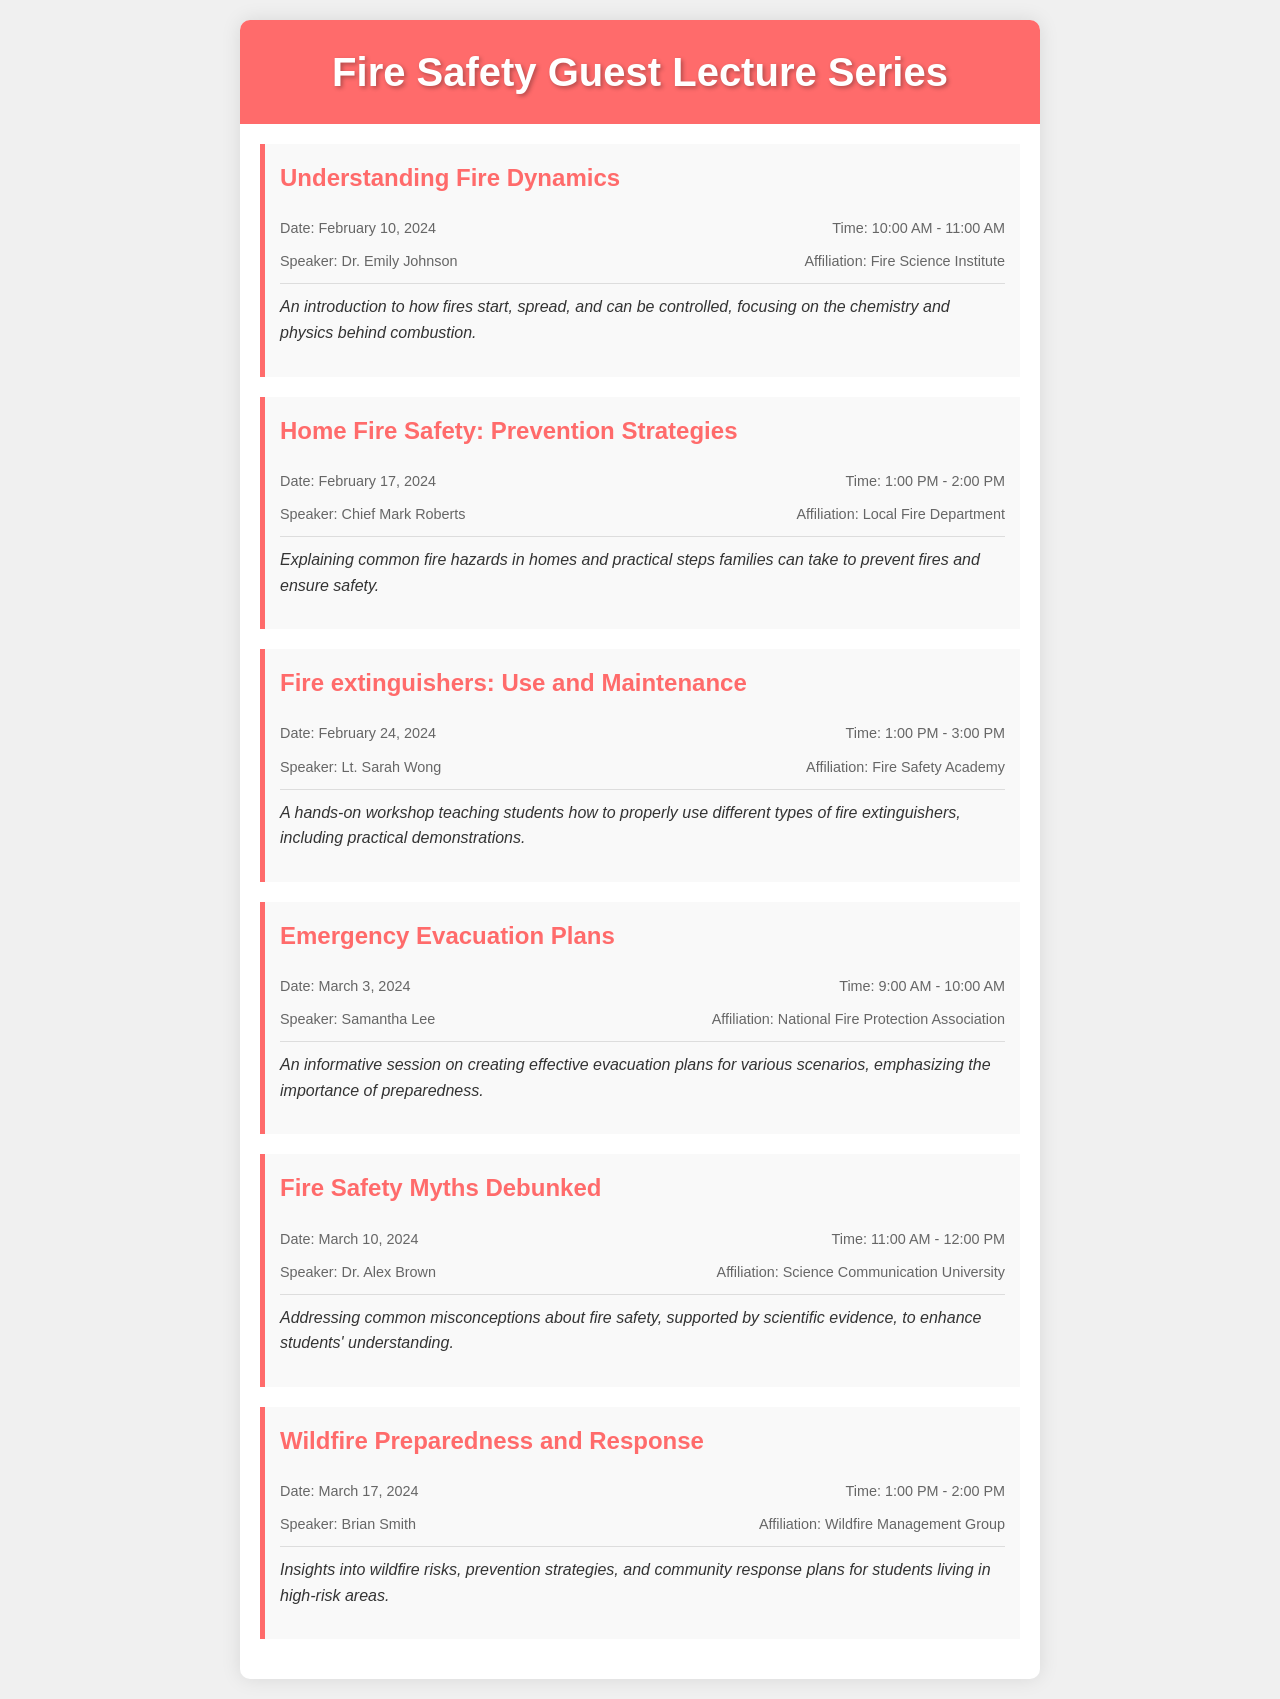What is the title of the first lecture? The title of the first lecture is found in the document under the event section, which is "Understanding Fire Dynamics."
Answer: Understanding Fire Dynamics Who is the speaker for the Home Fire Safety lecture? The speaker for the Home Fire Safety lecture is noted in the event details as Chief Mark Roberts.
Answer: Chief Mark Roberts What date is the Fire extinguishers workshop scheduled? The date for the Fire extinguishers workshop can be extracted from the event details, which states February 24, 2024.
Answer: February 24, 2024 How long is the Emergency Evacuation Plans session? The duration of the Emergency Evacuation Plans session is indicated by the time details, which are 9:00 AM to 10:00 AM.
Answer: 1 hour What organization is affiliated with the speaker for Wildfire Preparedness? The organization associated with the speaker for the Wildfire Preparedness session is mentioned as the Wildfire Management Group.
Answer: Wildfire Management Group How many lectures are scheduled in total? The total number of lectures can be counted from the event sections listed in the document, which shows six events.
Answer: 6 What is the main focus of the Fire Safety Myths lecture? The main focus of the Fire Safety Myths lecture is described in the event description, which is addressing common misconceptions about fire safety.
Answer: Common misconceptions about fire safety What time does the first lecture start? The starting time for the first lecture can be found in the schedule details, which is 10:00 AM.
Answer: 10:00 AM What is the focus of the lecture given by Lt. Sarah Wong? The focus of the lecture provided by Lt. Sarah Wong is detailed in the event description about the use and maintenance of fire extinguishers.
Answer: Use and Maintenance of Fire Extinguishers 